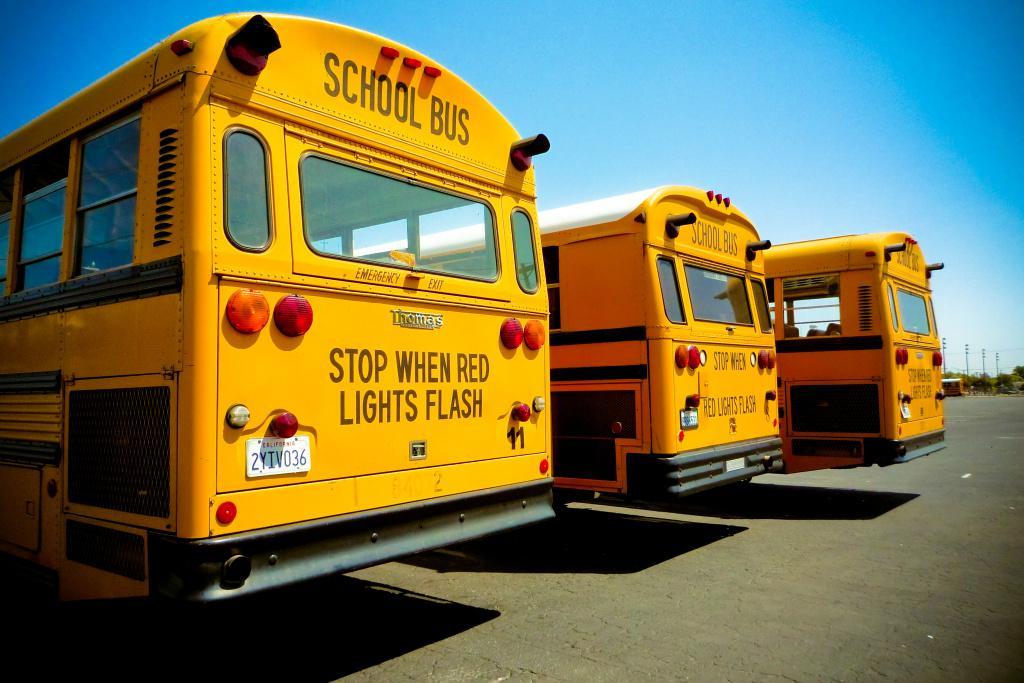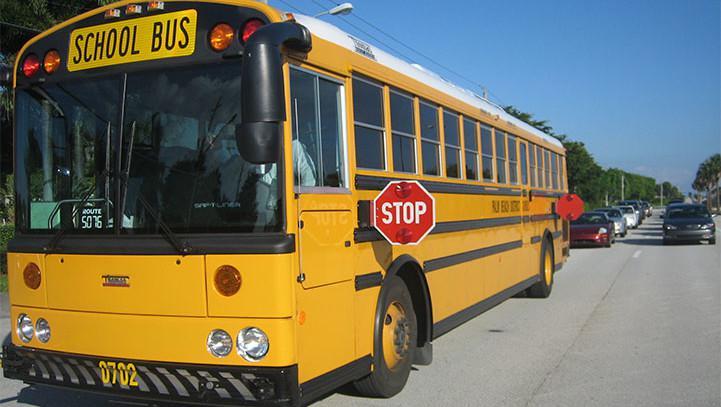The first image is the image on the left, the second image is the image on the right. Considering the images on both sides, is "There are more buses in the image on the right." valid? Answer yes or no. No. The first image is the image on the left, the second image is the image on the right. Assess this claim about the two images: "One image shows the back of three or more school buses parked at an angle, while a second image shows the front of one bus.". Correct or not? Answer yes or no. Yes. 